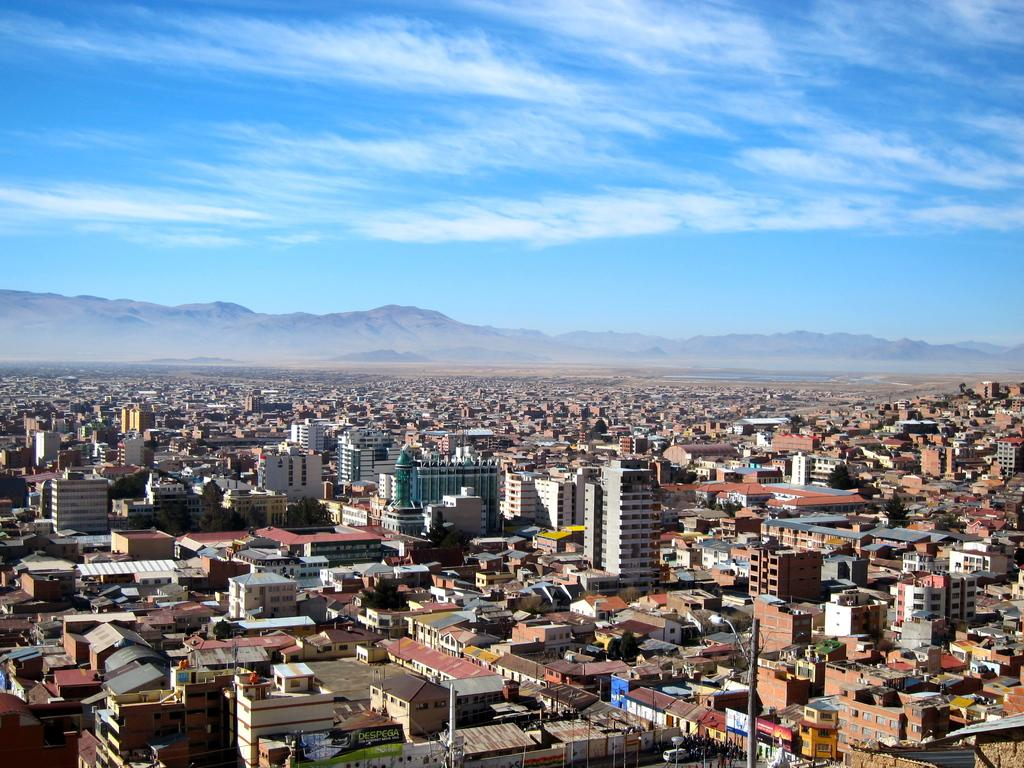What type of structures can be seen in the image? There are many buildings in the image. What other natural elements are present in the image? There are trees and mountains in the image. What man-made objects can be seen in the image? There are poles and lights in the image. Are there any signs or messages in the image? Yes, there are boards with text in the image. What can be seen in the background of the image? The sky is visible in the background of the image, and clouds are present in the sky. What type of soap is being used to clean the buildings in the image? There is no soap present in the image, and the buildings are not being cleaned. How does the behavior of the clouds in the image affect the buildings? The clouds in the image do not have any behavior that affects the buildings; they are simply a part of the sky's background. 